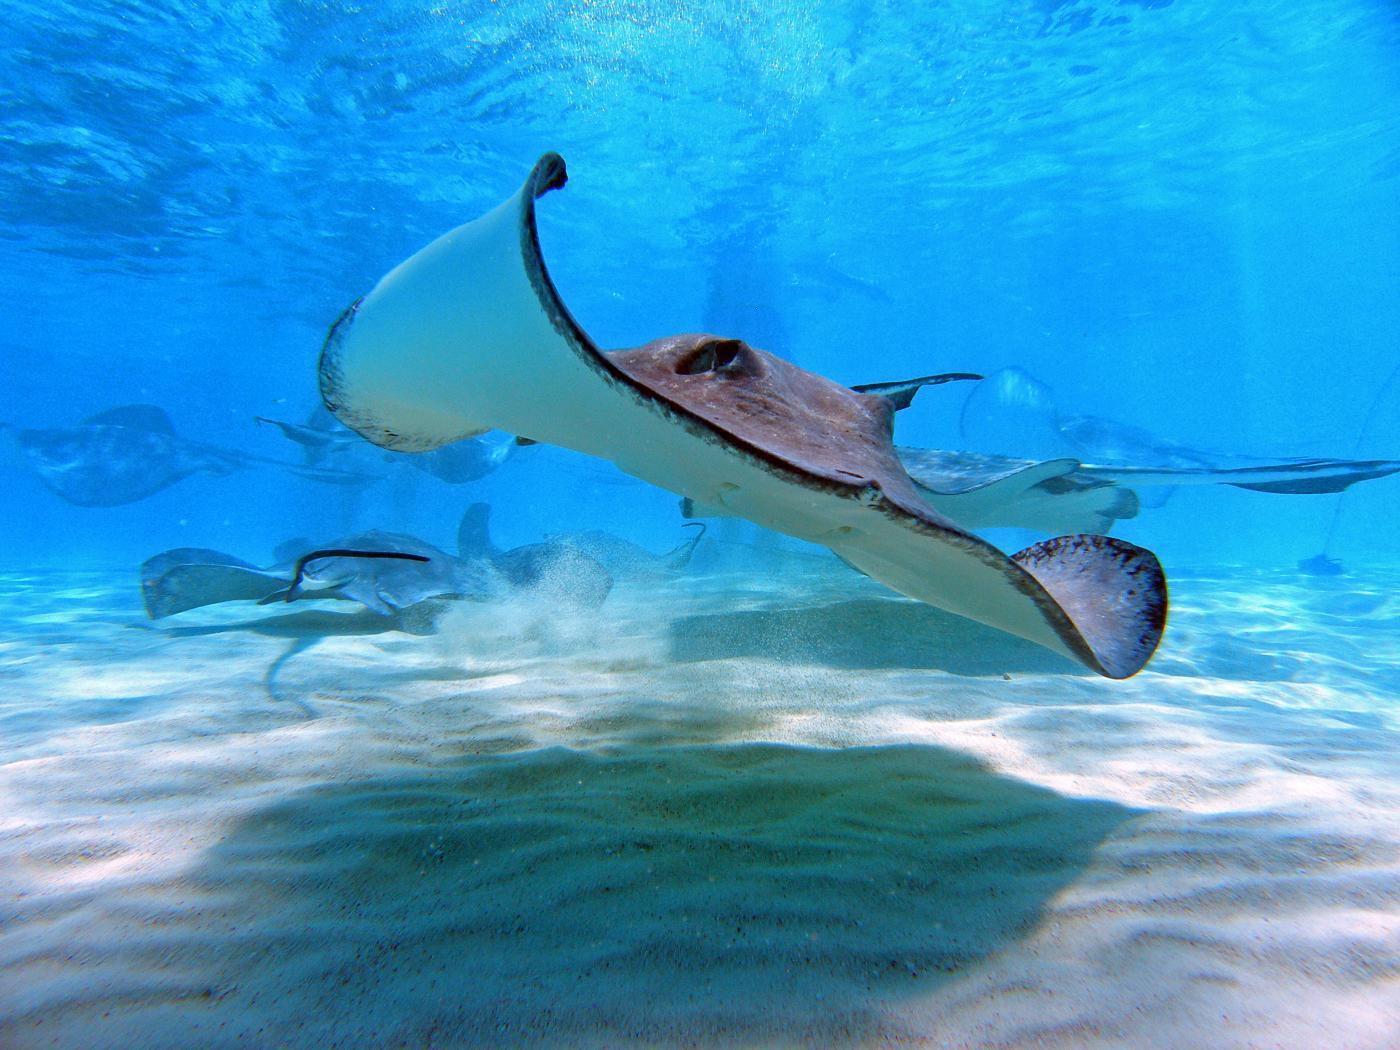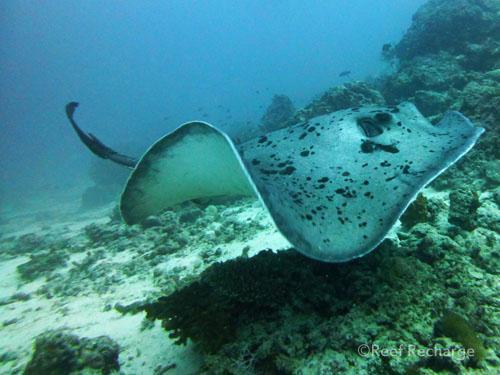The first image is the image on the left, the second image is the image on the right. For the images displayed, is the sentence "One image shows the underbelly of a stingray in the foreground, and the other shows the top view of a dark blue stingray without distinctive spots." factually correct? Answer yes or no. No. The first image is the image on the left, the second image is the image on the right. Given the left and right images, does the statement "The stingray on the right image is touching sand." hold true? Answer yes or no. No. 